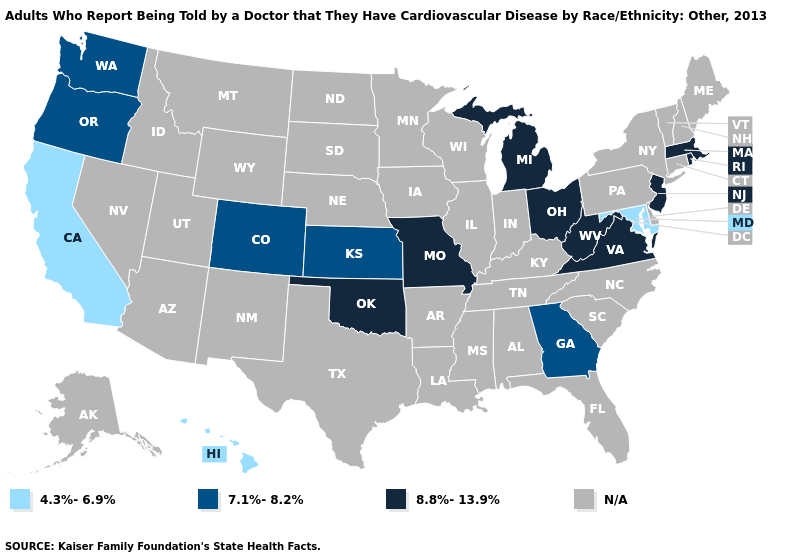What is the lowest value in the MidWest?
Keep it brief. 7.1%-8.2%. Among the states that border Kansas , does Oklahoma have the highest value?
Quick response, please. Yes. What is the value of Minnesota?
Short answer required. N/A. Does the first symbol in the legend represent the smallest category?
Answer briefly. Yes. Among the states that border Arizona , which have the highest value?
Answer briefly. Colorado. Among the states that border Illinois , which have the highest value?
Concise answer only. Missouri. Name the states that have a value in the range 8.8%-13.9%?
Answer briefly. Massachusetts, Michigan, Missouri, New Jersey, Ohio, Oklahoma, Rhode Island, Virginia, West Virginia. What is the value of Missouri?
Give a very brief answer. 8.8%-13.9%. What is the value of South Carolina?
Answer briefly. N/A. Name the states that have a value in the range 7.1%-8.2%?
Answer briefly. Colorado, Georgia, Kansas, Oregon, Washington. Name the states that have a value in the range 4.3%-6.9%?
Concise answer only. California, Hawaii, Maryland. Does Oregon have the highest value in the USA?
Keep it brief. No. Does California have the lowest value in the USA?
Be succinct. Yes. What is the highest value in states that border New Hampshire?
Quick response, please. 8.8%-13.9%. 